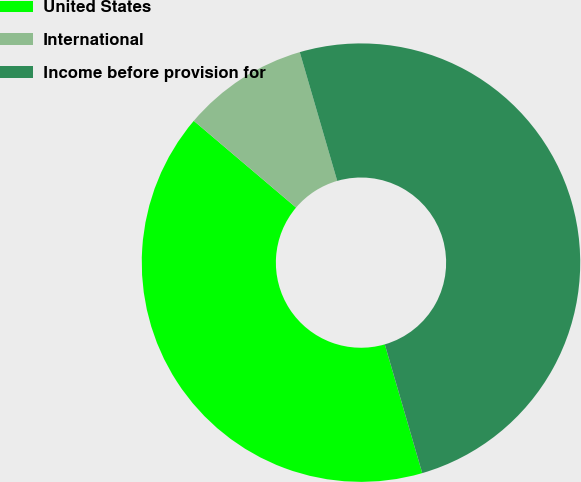Convert chart. <chart><loc_0><loc_0><loc_500><loc_500><pie_chart><fcel>United States<fcel>International<fcel>Income before provision for<nl><fcel>40.7%<fcel>9.3%<fcel>50.0%<nl></chart> 